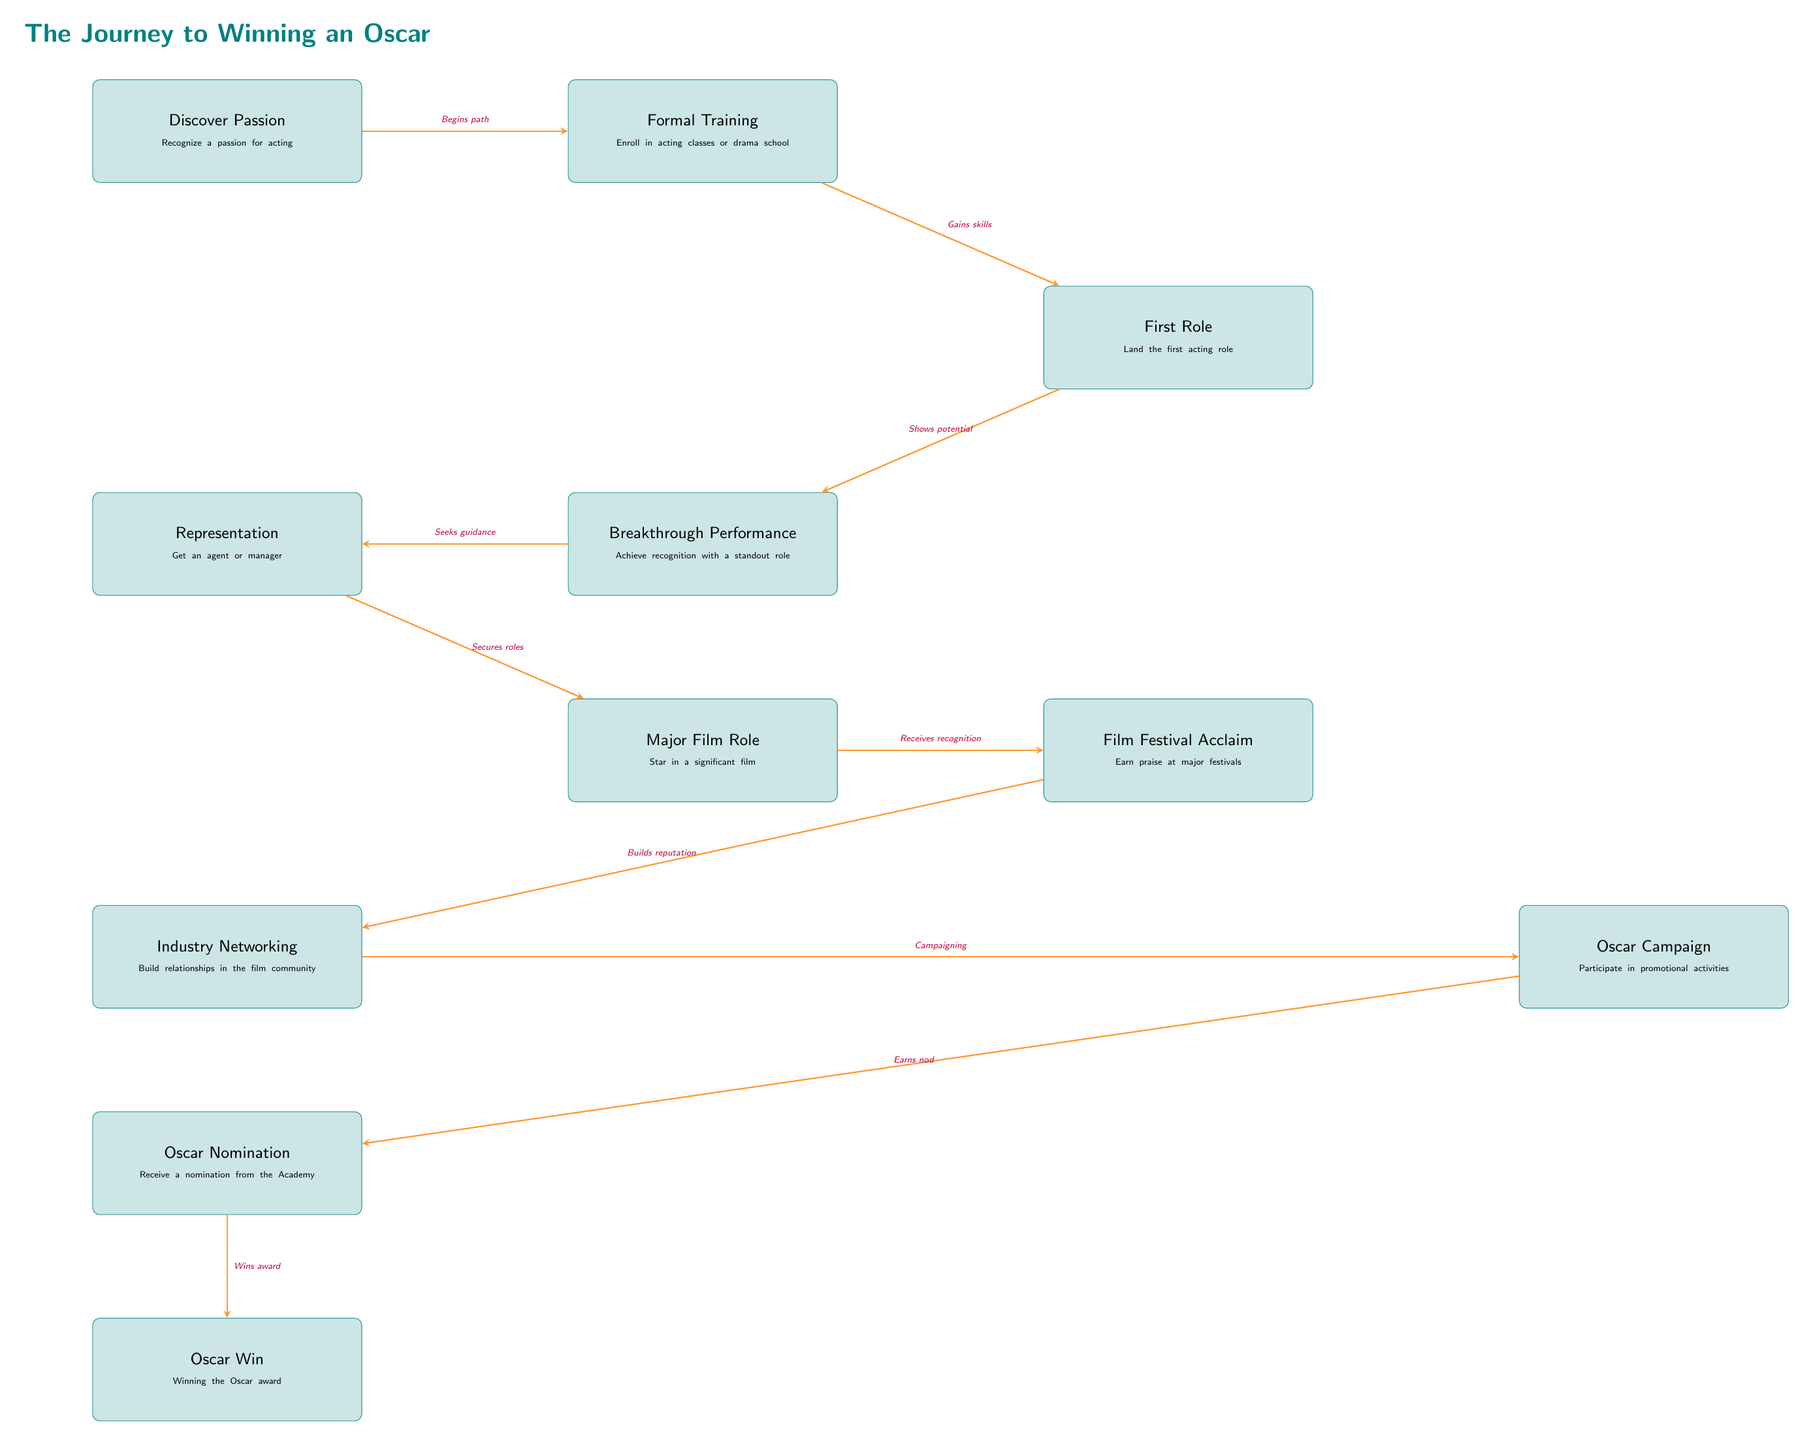What is the first milestone in the journey? The first milestone listed in the diagram is "Discover Passion," which indicates the initial step where an individual recognizes their passion for acting.
Answer: Discover Passion How many major milestones are shown in the diagram? The diagram includes a total of 11 major milestones from "Discover Passion" to "Oscar Win."
Answer: 11 What is the role of "Representation" in the journey? "Representation" occurs after the "Breakthrough Performance" and before "Major Film Role," signifying the importance of securing an agent or manager in advancing one's career.
Answer: Get an agent or manager Which milestone is positioned directly after "Oscar Nominated"? "Oscar Win" is the milestone that directly follows "Oscar Nomination," indicating the final achievement in the Oscar journey.
Answer: Oscar Win What connection exists between "Film Festival Acclaim" and "Oscar Campaign"? The connection indicates that after receiving acclaim from film festivals, the next step is participating in promotional activities or the Oscar Campaign, showcasing a transition from recognition to proactive efforts.
Answer: Campaigning What does the arrow from "Breakthrough Performance" to "Representation" signify? The arrow denotes the action of seeking guidance, indicating that recognition from a standout role leads one to seek representation to further their career.
Answer: Seeks guidance How does "Major Film Role" contribute to "Oscar Campaign"? "Major Film Role" creates a significant performance that ultimately leads to acclaim, establishing a candidate's reputation before initiating an Oscar Campaign, linking the performance to the awards process.
Answer: Receives recognition Which milestone indicates gaining acting skills? "Formal Training" is identified as the milestone signifying the acquisition of acting skills through classes or drama school enrollment.
Answer: Enroll in acting classes or drama school What does the label on the arrow between "Film Festival Acclaim" and "Industry Networking" mean? The label states 'Builds reputation,' indicating that acclaim at film festivals contributes to the actor's reputation, helping them network within the industry.
Answer: Builds reputation 